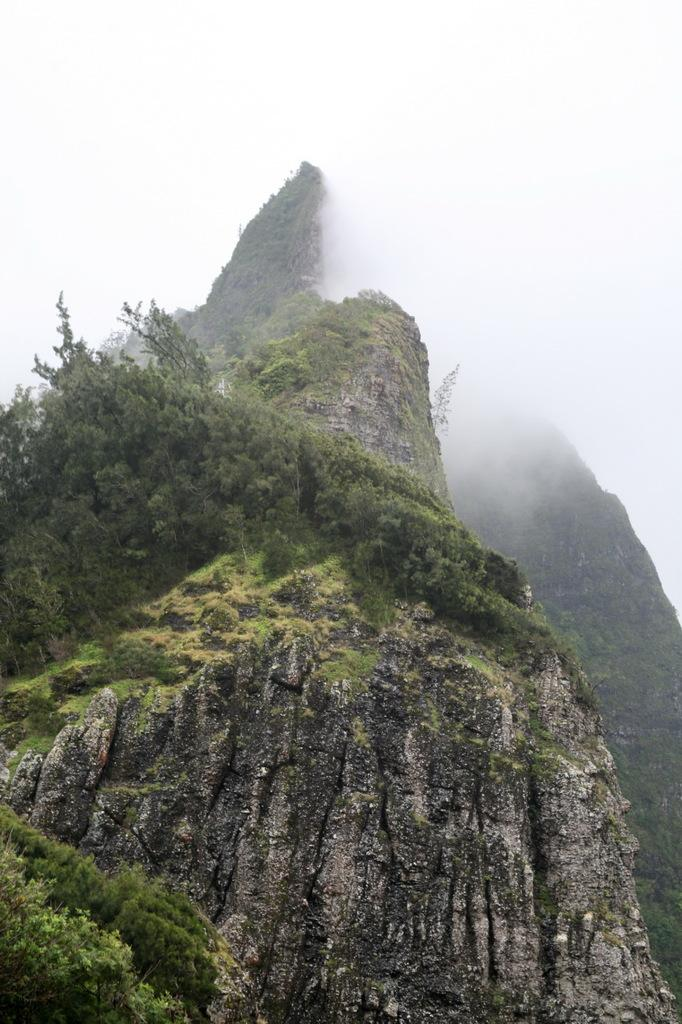What type of natural landscape is depicted in the image? The image features mountains, grass, and trees, which are all elements of a natural landscape. What can be seen in the background of the image? The sky and fog are visible in the background of the image. What type of vegetation is present in the image? There are trees in the image. How does the beggar in the image draw attention to their cause? There is no beggar present in the image; it features a natural landscape with mountains, grass, trees, and a sky with fog in the background. 